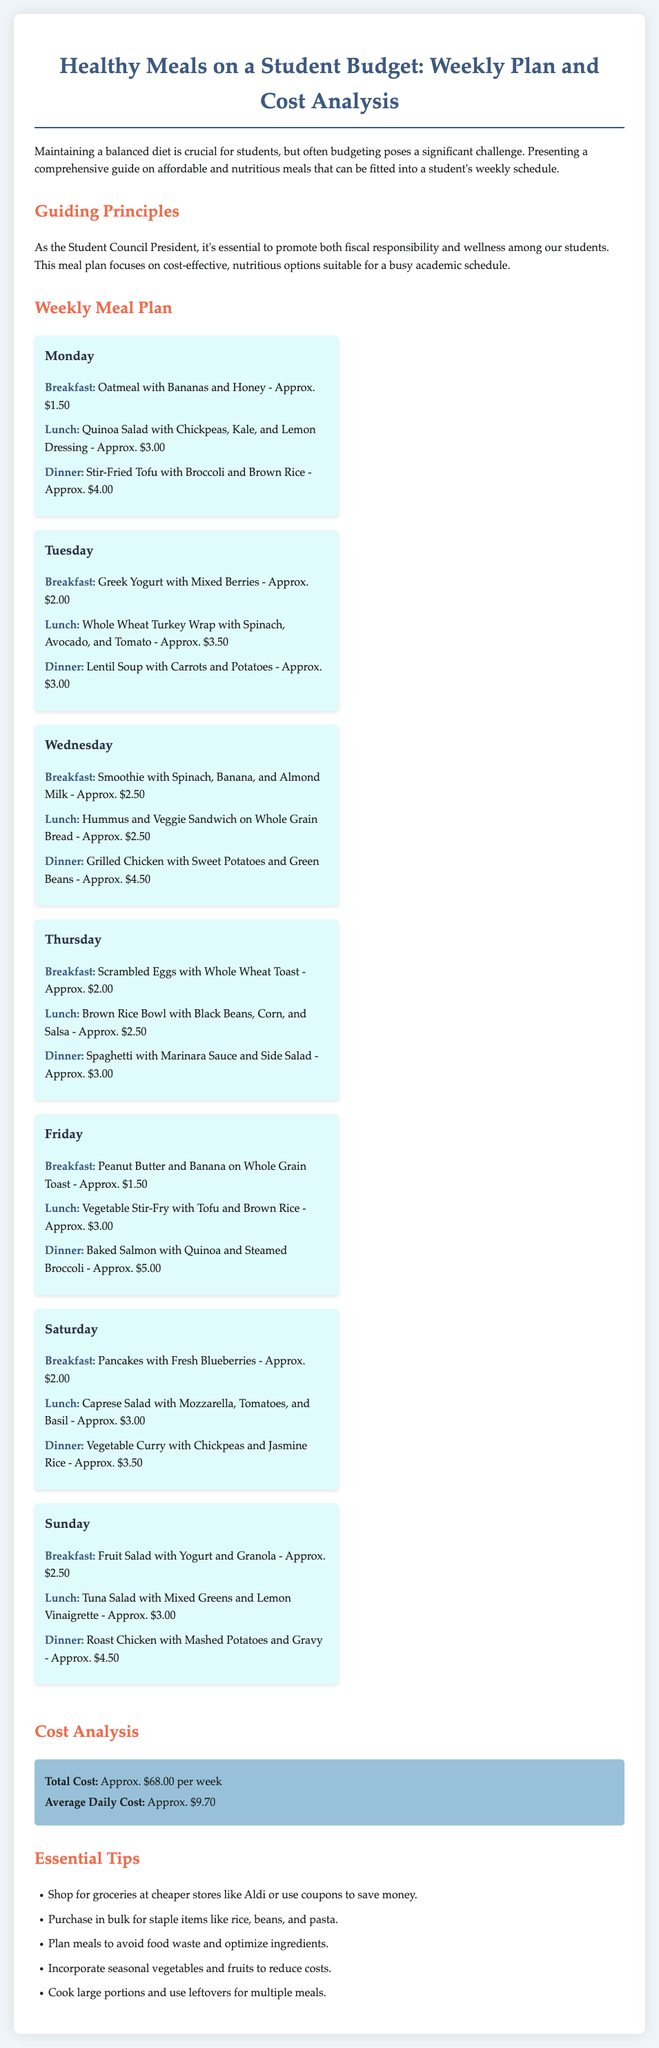what is the total cost for the week? The total cost is calculated from all meals from Monday to Sunday, resulting in approximately $68.00.
Answer: $68.00 what is the average daily cost? The average daily cost is calculated by dividing the total weekly cost by 7 days, resulting in approximately $9.70.
Answer: $9.70 what meal is suggested for Wednesday dinner? The meal for Wednesday dinner is listed as grilled chicken with sweet potatoes and green beans.
Answer: Grilled Chicken with Sweet Potatoes and Green Beans how much does a Greek yogurt with mixed berries cost? The cost for Greek yogurt with mixed berries for breakfast on Tuesday is stated to be approximately $2.00.
Answer: $2.00 which day features a vegetable curry? The vegetable curry is included in the Saturday dinner options, highlighting the chosen meal.
Answer: Saturday what is a tip for shopping groceries? One of the essential tips suggests shopping for groceries at cheaper stores like Aldi or using coupons to save money.
Answer: Shop at cheaper stores how many meals are included in the weekly plan? There are a total of 21 meals included in the weekly plan, with three meals per day over seven days.
Answer: 21 meals what is the primary focus of this meal plan? The primary focus highlighted in the document is on cost-effective, nutritious options for students.
Answer: Cost-effective nutritious options which meal is the cheapest on Monday? The cheapest meal on Monday is oatmeal with bananas and honey, which costs approximately $1.50.
Answer: Oatmeal with Bananas and Honey 